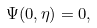Convert formula to latex. <formula><loc_0><loc_0><loc_500><loc_500>\Psi ( 0 , \eta ) = 0 ,</formula> 